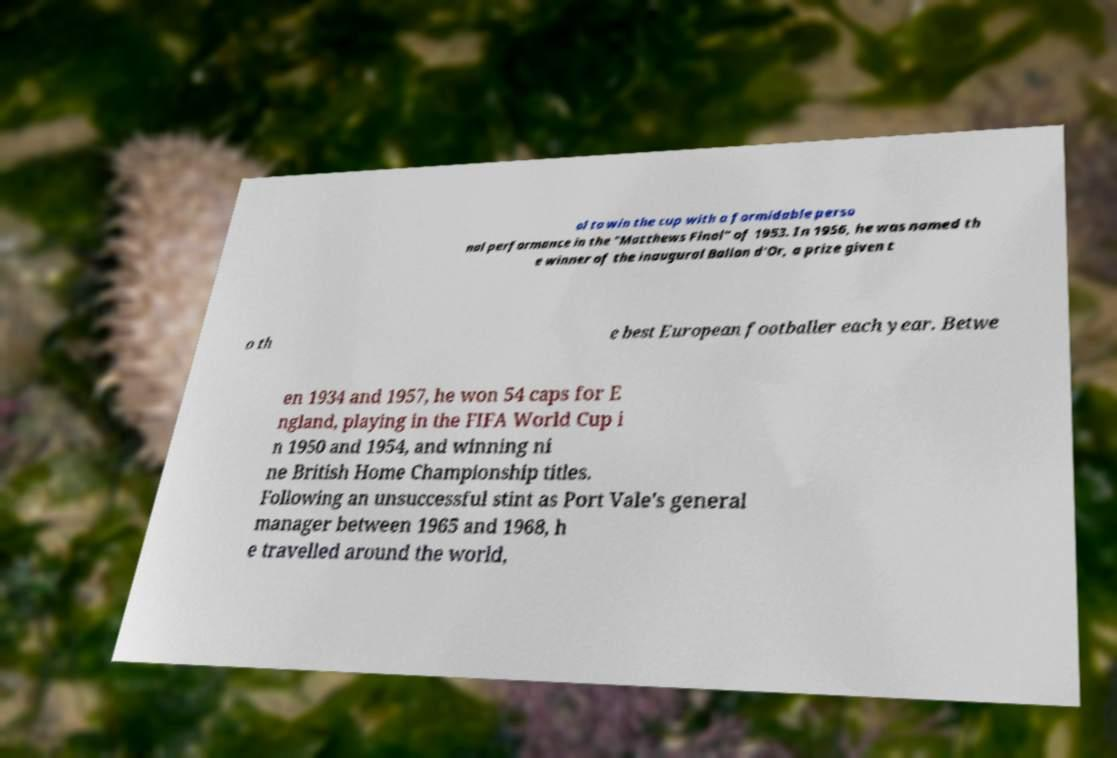Can you accurately transcribe the text from the provided image for me? ol to win the cup with a formidable perso nal performance in the "Matthews Final" of 1953. In 1956, he was named th e winner of the inaugural Ballon d'Or, a prize given t o th e best European footballer each year. Betwe en 1934 and 1957, he won 54 caps for E ngland, playing in the FIFA World Cup i n 1950 and 1954, and winning ni ne British Home Championship titles. Following an unsuccessful stint as Port Vale's general manager between 1965 and 1968, h e travelled around the world, 